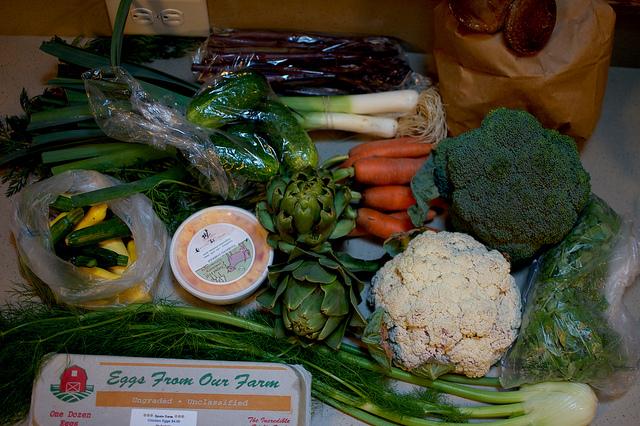Name 3 vegetables?
Write a very short answer. Carrots, broccoli, cauliflower. What kind of bird is mentioned on box on left?
Be succinct. Chicken. What dairy products?
Answer briefly. Eggs. What color are the carrots?
Be succinct. Orange. What kind of carrots are in the bag?
Give a very brief answer. Orange. What language is shown?
Be succinct. English. What meal is this person planning on making?
Be succinct. Salad. What is the yogurt brand?
Write a very short answer. Dannon. Is there any broccoli in this photo?
Concise answer only. Yes. 